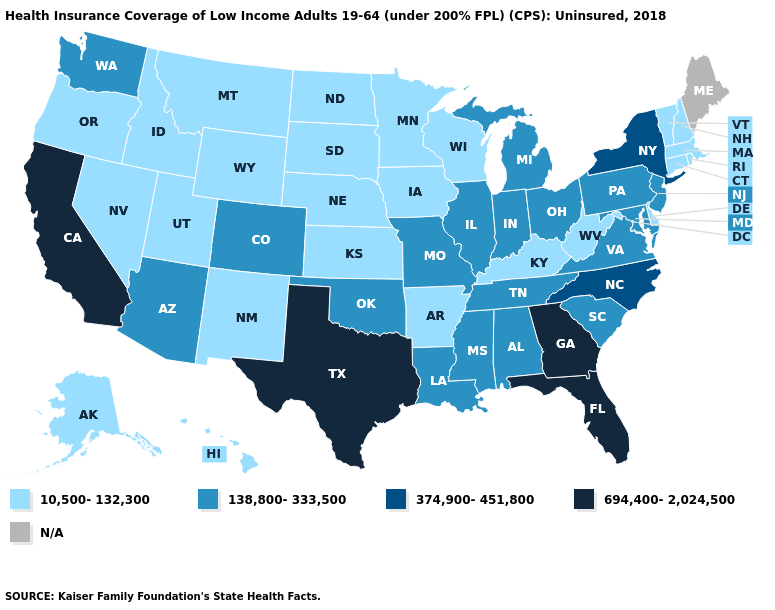Which states have the lowest value in the USA?
Write a very short answer. Alaska, Arkansas, Connecticut, Delaware, Hawaii, Idaho, Iowa, Kansas, Kentucky, Massachusetts, Minnesota, Montana, Nebraska, Nevada, New Hampshire, New Mexico, North Dakota, Oregon, Rhode Island, South Dakota, Utah, Vermont, West Virginia, Wisconsin, Wyoming. Does Kentucky have the lowest value in the South?
Short answer required. Yes. Which states have the highest value in the USA?
Give a very brief answer. California, Florida, Georgia, Texas. Does the first symbol in the legend represent the smallest category?
Keep it brief. Yes. Does New Mexico have the highest value in the West?
Short answer required. No. What is the value of Utah?
Concise answer only. 10,500-132,300. Name the states that have a value in the range 374,900-451,800?
Concise answer only. New York, North Carolina. Name the states that have a value in the range 10,500-132,300?
Keep it brief. Alaska, Arkansas, Connecticut, Delaware, Hawaii, Idaho, Iowa, Kansas, Kentucky, Massachusetts, Minnesota, Montana, Nebraska, Nevada, New Hampshire, New Mexico, North Dakota, Oregon, Rhode Island, South Dakota, Utah, Vermont, West Virginia, Wisconsin, Wyoming. What is the value of Alabama?
Write a very short answer. 138,800-333,500. What is the lowest value in states that border South Carolina?
Give a very brief answer. 374,900-451,800. What is the value of Virginia?
Be succinct. 138,800-333,500. Among the states that border West Virginia , does Kentucky have the lowest value?
Keep it brief. Yes. What is the value of Illinois?
Write a very short answer. 138,800-333,500. Does New Hampshire have the highest value in the USA?
Answer briefly. No. Name the states that have a value in the range N/A?
Keep it brief. Maine. 